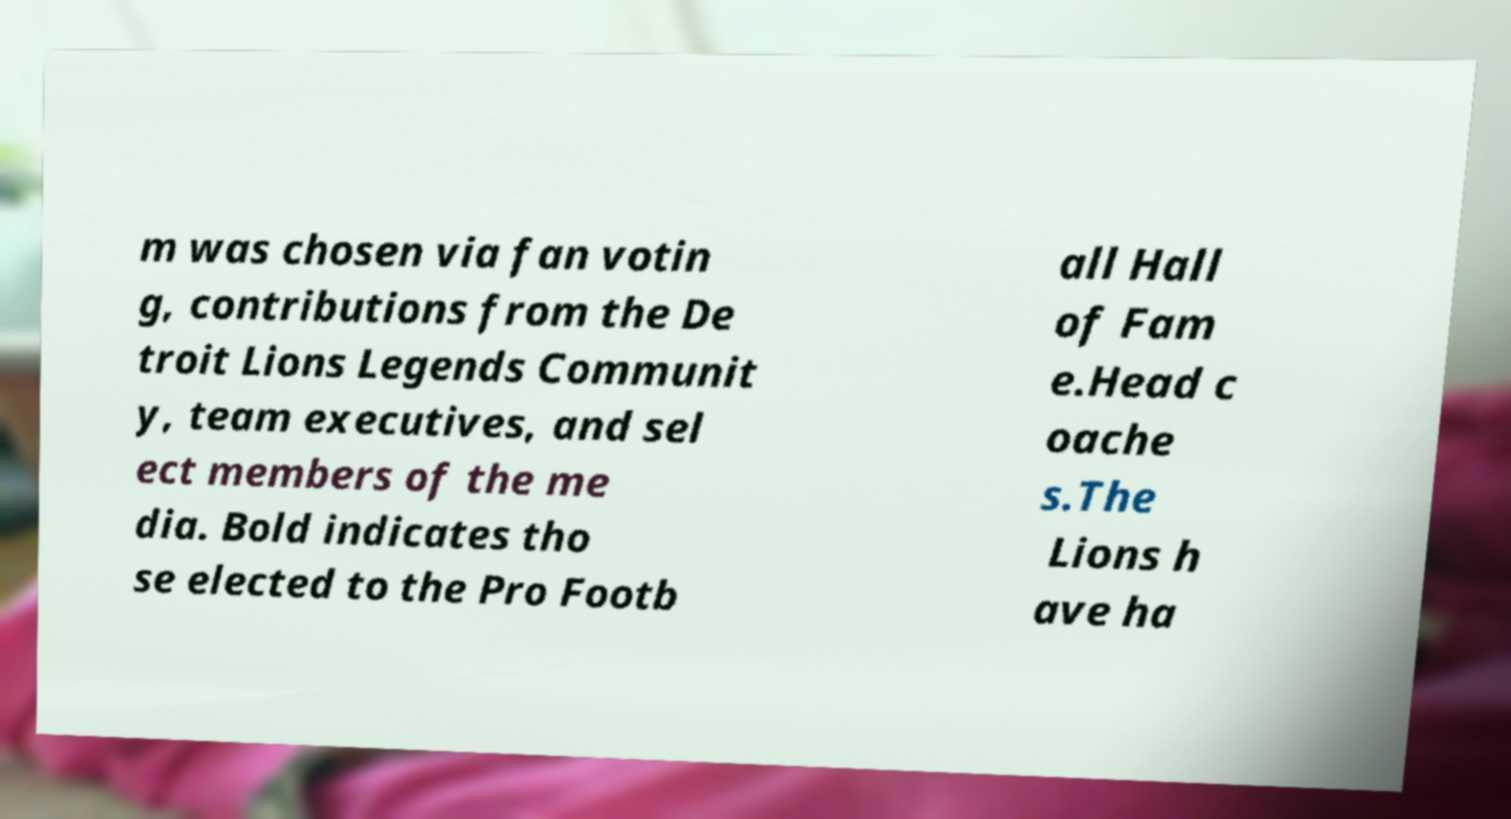Can you read and provide the text displayed in the image?This photo seems to have some interesting text. Can you extract and type it out for me? m was chosen via fan votin g, contributions from the De troit Lions Legends Communit y, team executives, and sel ect members of the me dia. Bold indicates tho se elected to the Pro Footb all Hall of Fam e.Head c oache s.The Lions h ave ha 